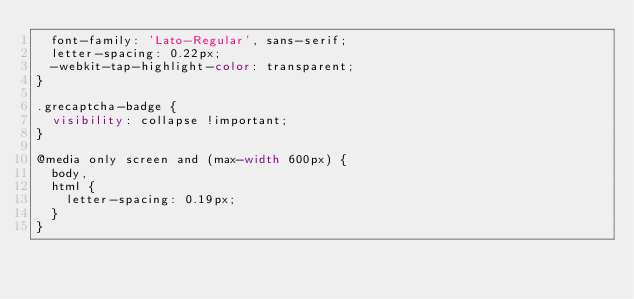<code> <loc_0><loc_0><loc_500><loc_500><_CSS_>  font-family: 'Lato-Regular', sans-serif;
  letter-spacing: 0.22px;
  -webkit-tap-highlight-color: transparent;
}

.grecaptcha-badge {
  visibility: collapse !important;
}

@media only screen and (max-width 600px) {
  body,
  html {
    letter-spacing: 0.19px;
  }
}
</code> 